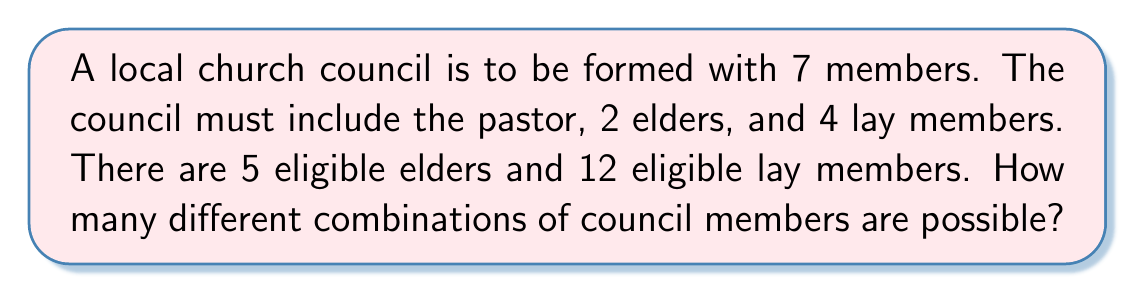Help me with this question. Let's break this down step-by-step:

1. The pastor is automatically included, so we don't need to calculate combinations for this position.

2. For the elders:
   - We need to choose 2 elders out of 5 eligible elders.
   - This is a combination problem, denoted as $\binom{5}{2}$ or $C(5,2)$.
   - The formula for this combination is:
     $$\binom{5}{2} = \frac{5!}{2!(5-2)!} = \frac{5!}{2!(3)!} = 10$$

3. For the lay members:
   - We need to choose 4 lay members out of 12 eligible lay members.
   - This is another combination, denoted as $\binom{12}{4}$ or $C(12,4)$.
   - The formula for this combination is:
     $$\binom{12}{4} = \frac{12!}{4!(12-4)!} = \frac{12!}{4!(8)!} = 495$$

4. To get the total number of possible combinations, we multiply the number of ways to choose elders by the number of ways to choose lay members:
   $$10 \times 495 = 4,950$$

Therefore, there are 4,950 different possible combinations of council members.
Answer: 4,950 